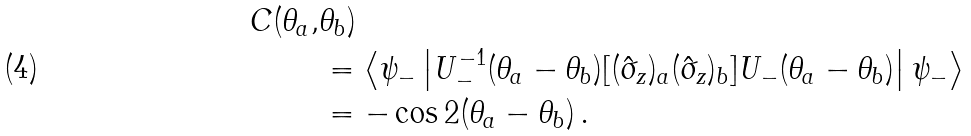Convert formula to latex. <formula><loc_0><loc_0><loc_500><loc_500>C ( \theta _ { a } , & \theta _ { b } ) \\ & = \left \langle \psi _ { - } \left | U _ { - } ^ { - 1 } ( \theta _ { a } - \theta _ { b } ) [ ( \hat { \sigma } _ { z } ) _ { a } ( \hat { \sigma } _ { z } ) _ { b } ] U _ { - } ( \theta _ { a } - \theta _ { b } ) \right | \psi _ { - } \right \rangle \\ & = - \cos 2 ( \theta _ { a } - \theta _ { b } ) \, .</formula> 